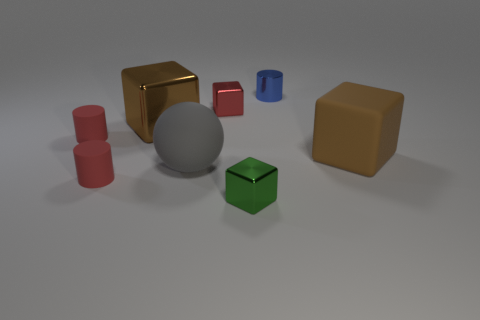What material is the other block that is the same color as the big matte block?
Make the answer very short. Metal. There is a matte object that is to the right of the blue shiny object; what is its shape?
Your answer should be very brief. Cube. What number of gray balls are there?
Your response must be concise. 1. The large block that is the same material as the tiny green thing is what color?
Your response must be concise. Brown. What number of tiny things are blue rubber balls or matte cylinders?
Keep it short and to the point. 2. There is a tiny blue metallic cylinder; what number of small shiny cylinders are behind it?
Provide a succinct answer. 0. The other big object that is the same shape as the brown matte object is what color?
Your response must be concise. Brown. What number of matte objects are small yellow things or small red cubes?
Offer a very short reply. 0. Are there any large gray objects in front of the tiny matte thing that is in front of the large matte object that is behind the gray ball?
Keep it short and to the point. No. What is the color of the rubber sphere?
Provide a short and direct response. Gray. 